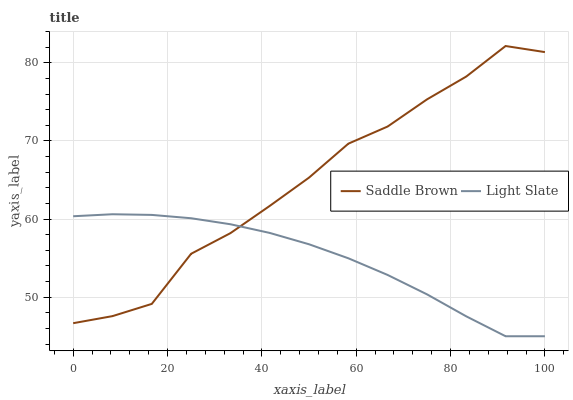Does Light Slate have the minimum area under the curve?
Answer yes or no. Yes. Does Saddle Brown have the maximum area under the curve?
Answer yes or no. Yes. Does Saddle Brown have the minimum area under the curve?
Answer yes or no. No. Is Light Slate the smoothest?
Answer yes or no. Yes. Is Saddle Brown the roughest?
Answer yes or no. Yes. Is Saddle Brown the smoothest?
Answer yes or no. No. Does Light Slate have the lowest value?
Answer yes or no. Yes. Does Saddle Brown have the lowest value?
Answer yes or no. No. Does Saddle Brown have the highest value?
Answer yes or no. Yes. Does Saddle Brown intersect Light Slate?
Answer yes or no. Yes. Is Saddle Brown less than Light Slate?
Answer yes or no. No. Is Saddle Brown greater than Light Slate?
Answer yes or no. No. 